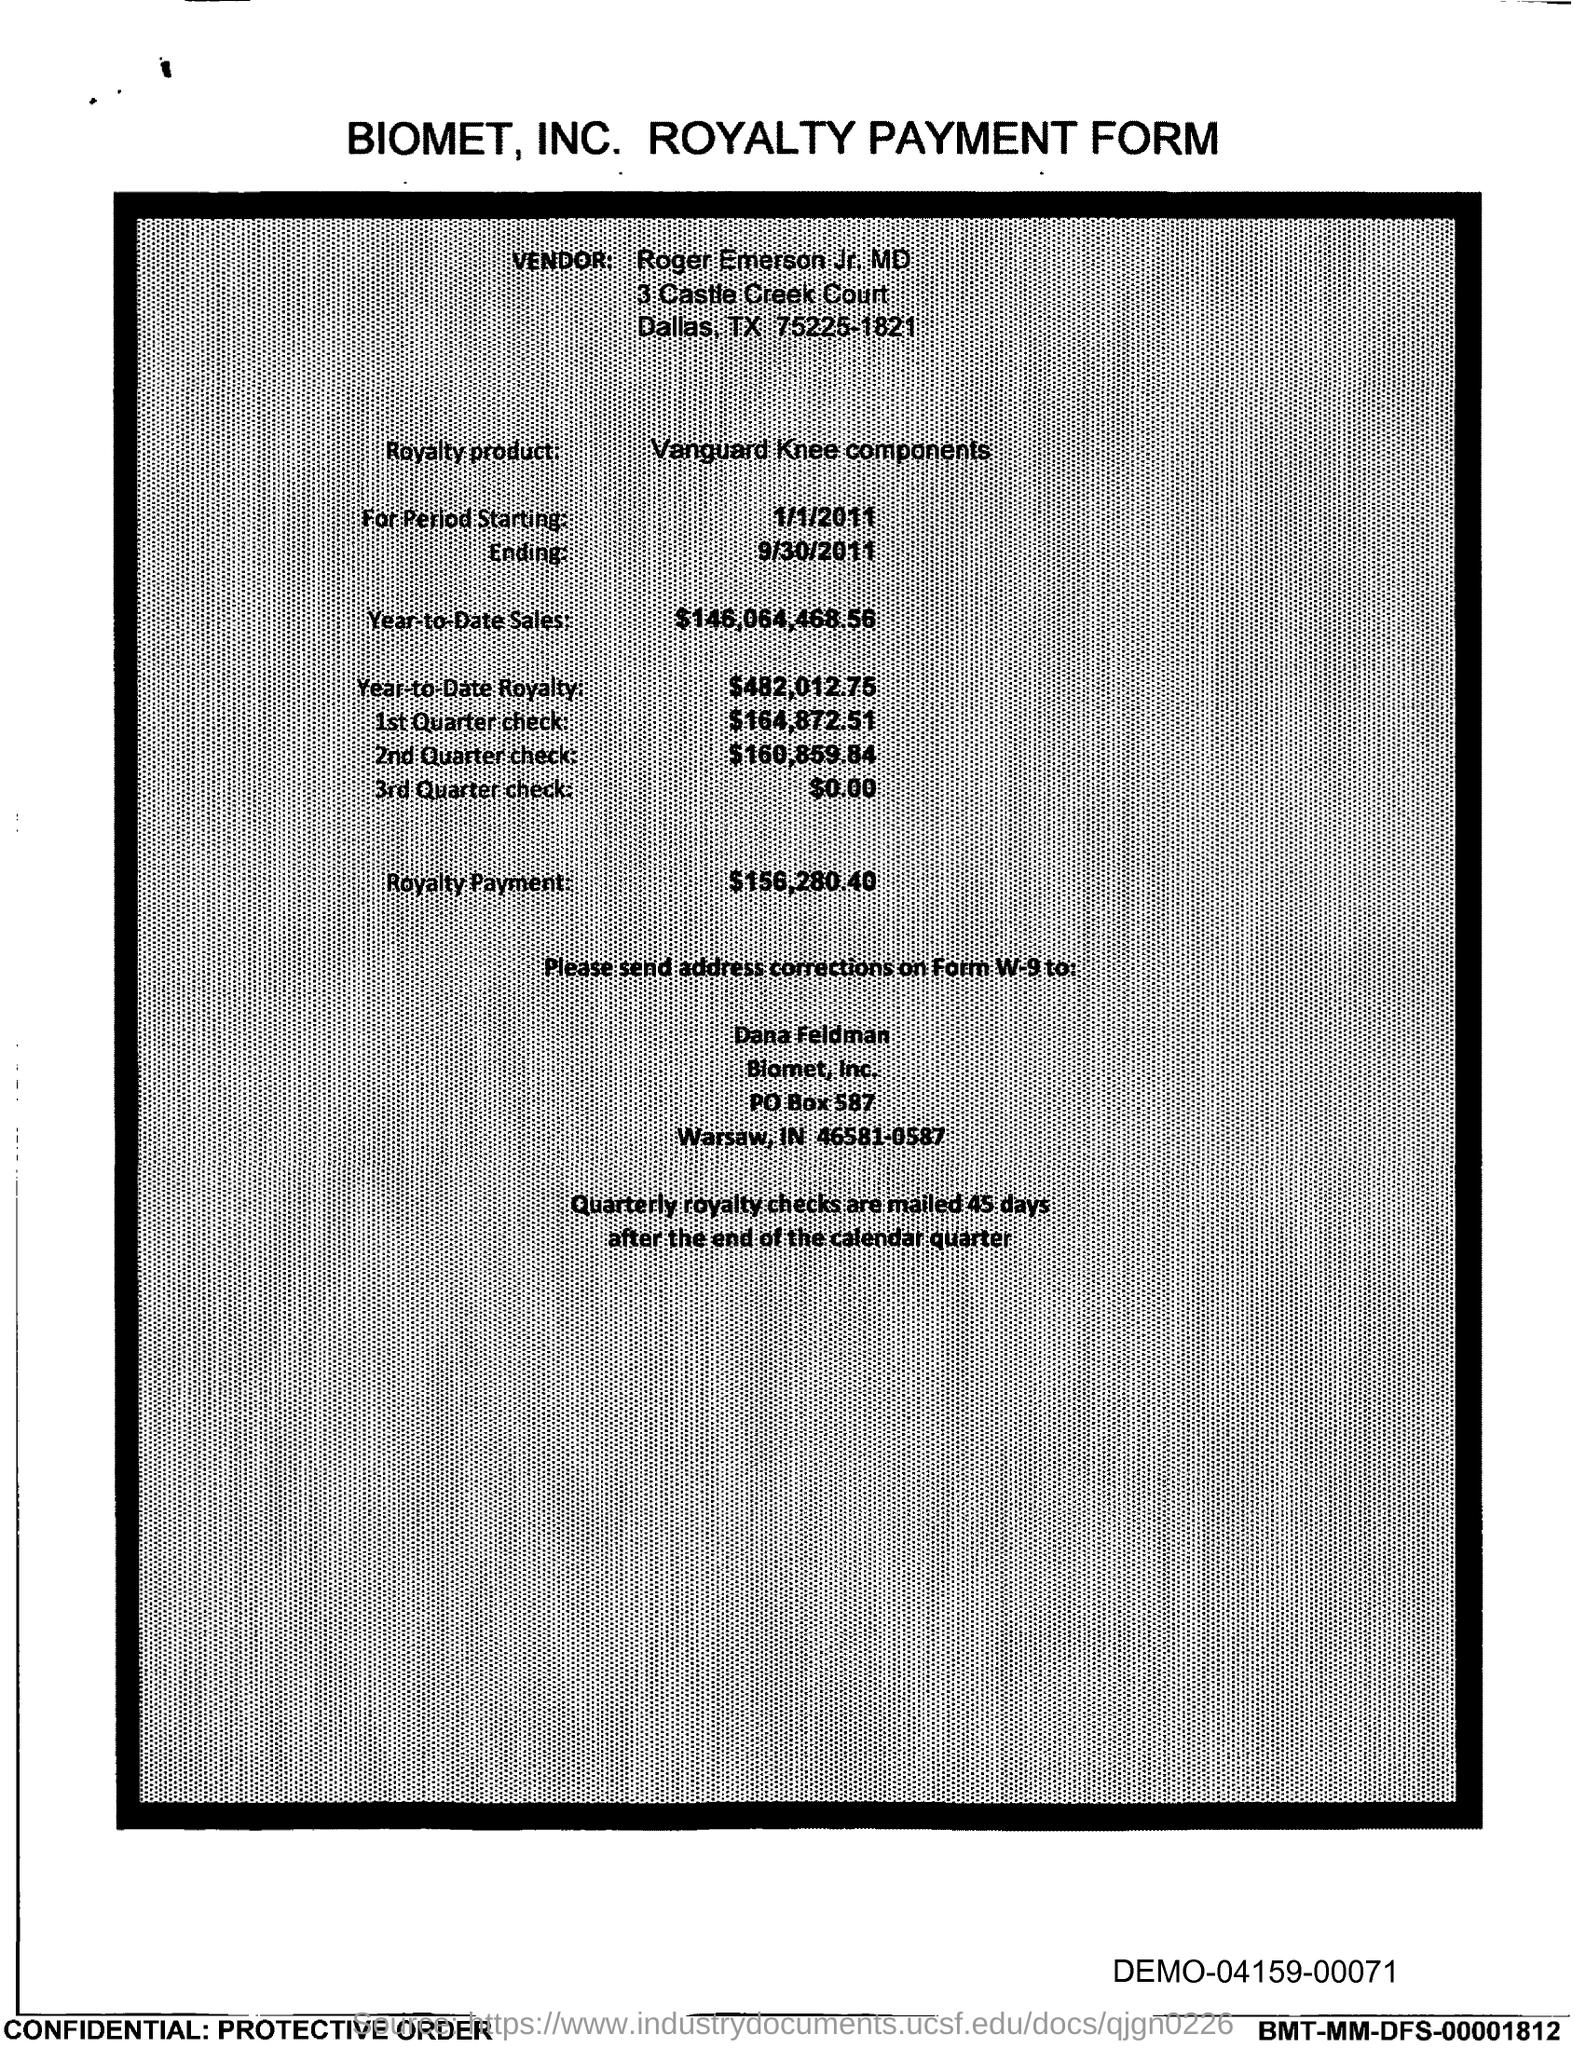What is the vendor name given in the form?
Ensure brevity in your answer.  Roger Emerson Jr. MD. What is the royalty product given in the form?
Give a very brief answer. Vanguard knee components. What is the Year-to-Date Sales of the royalty product?
Give a very brief answer. $146,064,468.56. What is the Year-to-Date royalty of the product?
Give a very brief answer. $482,012.75. What is the amount of 3rd Quarter check given in the form?
Your response must be concise. $0.00. What is the amount of 2nd Quarter check mentioned in the form?
Make the answer very short. $160,859.84. What is the amount of 1st quarter check mentioned in the form?
Keep it short and to the point. $164,872.51. What is the royalty payment of the product mentioned in the form?
Make the answer very short. $156,280.40. 